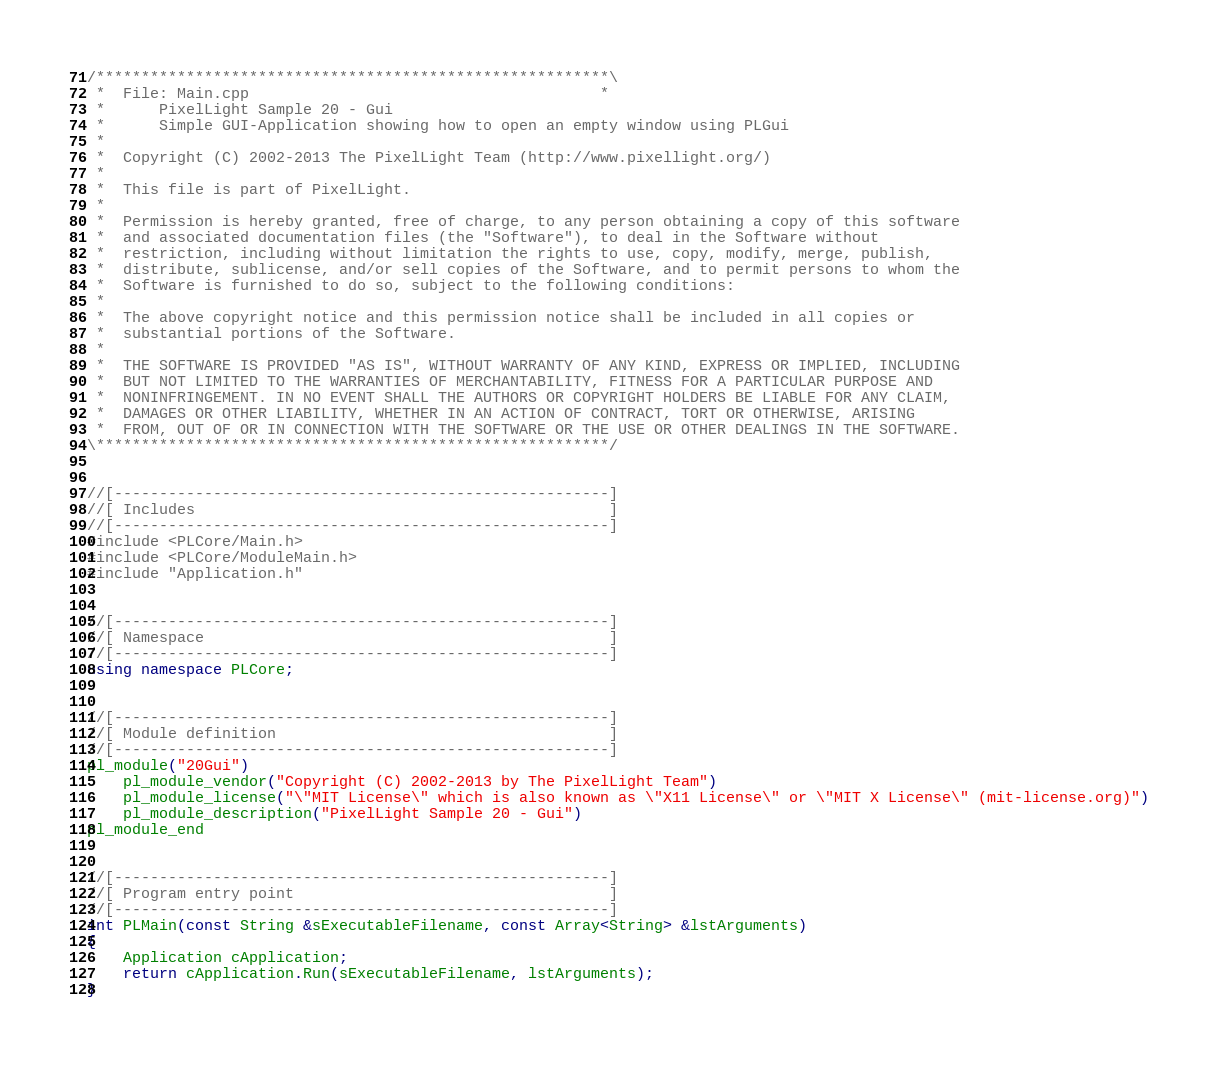Convert code to text. <code><loc_0><loc_0><loc_500><loc_500><_C++_>/*********************************************************\
 *  File: Main.cpp                                       *
 *      PixelLight Sample 20 - Gui
 *      Simple GUI-Application showing how to open an empty window using PLGui
 *
 *  Copyright (C) 2002-2013 The PixelLight Team (http://www.pixellight.org/)
 *
 *  This file is part of PixelLight.
 *
 *  Permission is hereby granted, free of charge, to any person obtaining a copy of this software
 *  and associated documentation files (the "Software"), to deal in the Software without
 *  restriction, including without limitation the rights to use, copy, modify, merge, publish,
 *  distribute, sublicense, and/or sell copies of the Software, and to permit persons to whom the
 *  Software is furnished to do so, subject to the following conditions:
 *
 *  The above copyright notice and this permission notice shall be included in all copies or
 *  substantial portions of the Software.
 *
 *  THE SOFTWARE IS PROVIDED "AS IS", WITHOUT WARRANTY OF ANY KIND, EXPRESS OR IMPLIED, INCLUDING
 *  BUT NOT LIMITED TO THE WARRANTIES OF MERCHANTABILITY, FITNESS FOR A PARTICULAR PURPOSE AND
 *  NONINFRINGEMENT. IN NO EVENT SHALL THE AUTHORS OR COPYRIGHT HOLDERS BE LIABLE FOR ANY CLAIM,
 *  DAMAGES OR OTHER LIABILITY, WHETHER IN AN ACTION OF CONTRACT, TORT OR OTHERWISE, ARISING
 *  FROM, OUT OF OR IN CONNECTION WITH THE SOFTWARE OR THE USE OR OTHER DEALINGS IN THE SOFTWARE.
\*********************************************************/


//[-------------------------------------------------------]
//[ Includes                                              ]
//[-------------------------------------------------------]
#include <PLCore/Main.h>
#include <PLCore/ModuleMain.h>
#include "Application.h"


//[-------------------------------------------------------]
//[ Namespace                                             ]
//[-------------------------------------------------------]
using namespace PLCore;


//[-------------------------------------------------------]
//[ Module definition                                     ]
//[-------------------------------------------------------]
pl_module("20Gui")
	pl_module_vendor("Copyright (C) 2002-2013 by The PixelLight Team")
	pl_module_license("\"MIT License\" which is also known as \"X11 License\" or \"MIT X License\" (mit-license.org)")
	pl_module_description("PixelLight Sample 20 - Gui")
pl_module_end


//[-------------------------------------------------------]
//[ Program entry point                                   ]
//[-------------------------------------------------------]
int PLMain(const String &sExecutableFilename, const Array<String> &lstArguments)
{
	Application cApplication;
	return cApplication.Run(sExecutableFilename, lstArguments);
}
</code> 